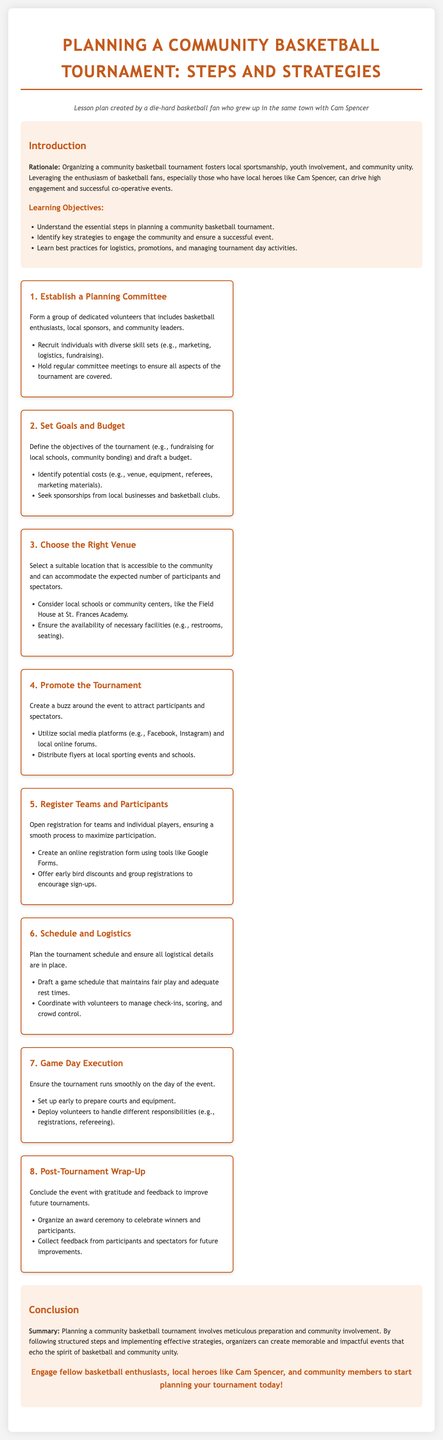What is the title of the document? The title is stated prominently at the top of the document as the main heading.
Answer: Planning a Community Basketball Tournament: Steps and Strategies Who is the persona behind the lesson plan? The persona is mentioned in the introductory paragraph as a die-hard basketball fan with a connection to a local player.
Answer: a die-hard basketball fan who grew up in the same town with Cam Spencer What is the first step in planning the tournament? The steps are laid out in numbered sections, with the first step clearly labeled.
Answer: Establish a Planning Committee What type of venue is suggested for the tournament? The document recommends considering specific types of locations for the event in the section about choosing a venue.
Answer: local schools or community centers What is one strategy suggested for promoting the tournament? Promotion strategies are listed, offering specific methods to attract participants.
Answer: Utilize social media platforms How many steps are outlined in the planning process? The steps are numbered sequentially, providing a clear count of the total proposed steps.
Answer: Eight What is mentioned in the conclusion about the community involvement? The conclusion summarizes the importance of community participation in making the event successful.
Answer: community involvement What should organizers collect post-tournament for future improvements? The document advises gathering specific types of feedback after the event’s conclusion.
Answer: feedback from participants and spectators 